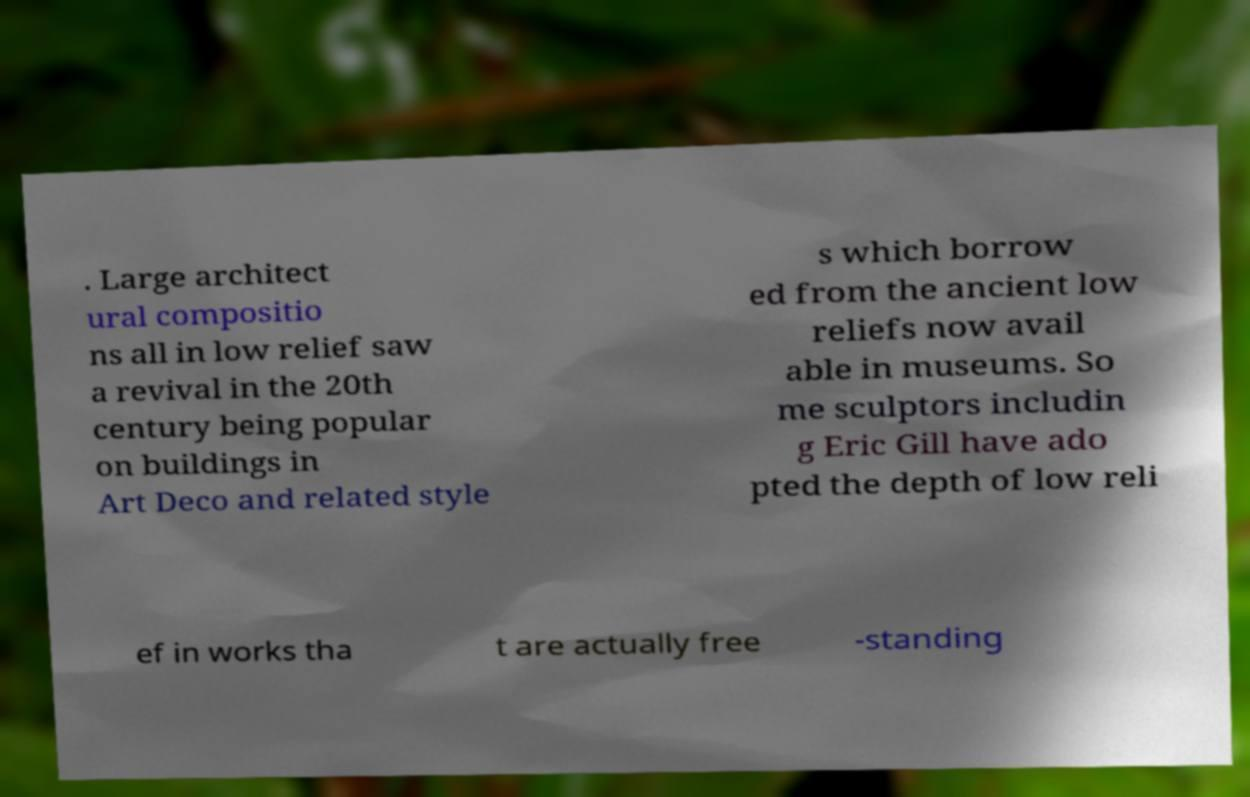Please identify and transcribe the text found in this image. . Large architect ural compositio ns all in low relief saw a revival in the 20th century being popular on buildings in Art Deco and related style s which borrow ed from the ancient low reliefs now avail able in museums. So me sculptors includin g Eric Gill have ado pted the depth of low reli ef in works tha t are actually free -standing 